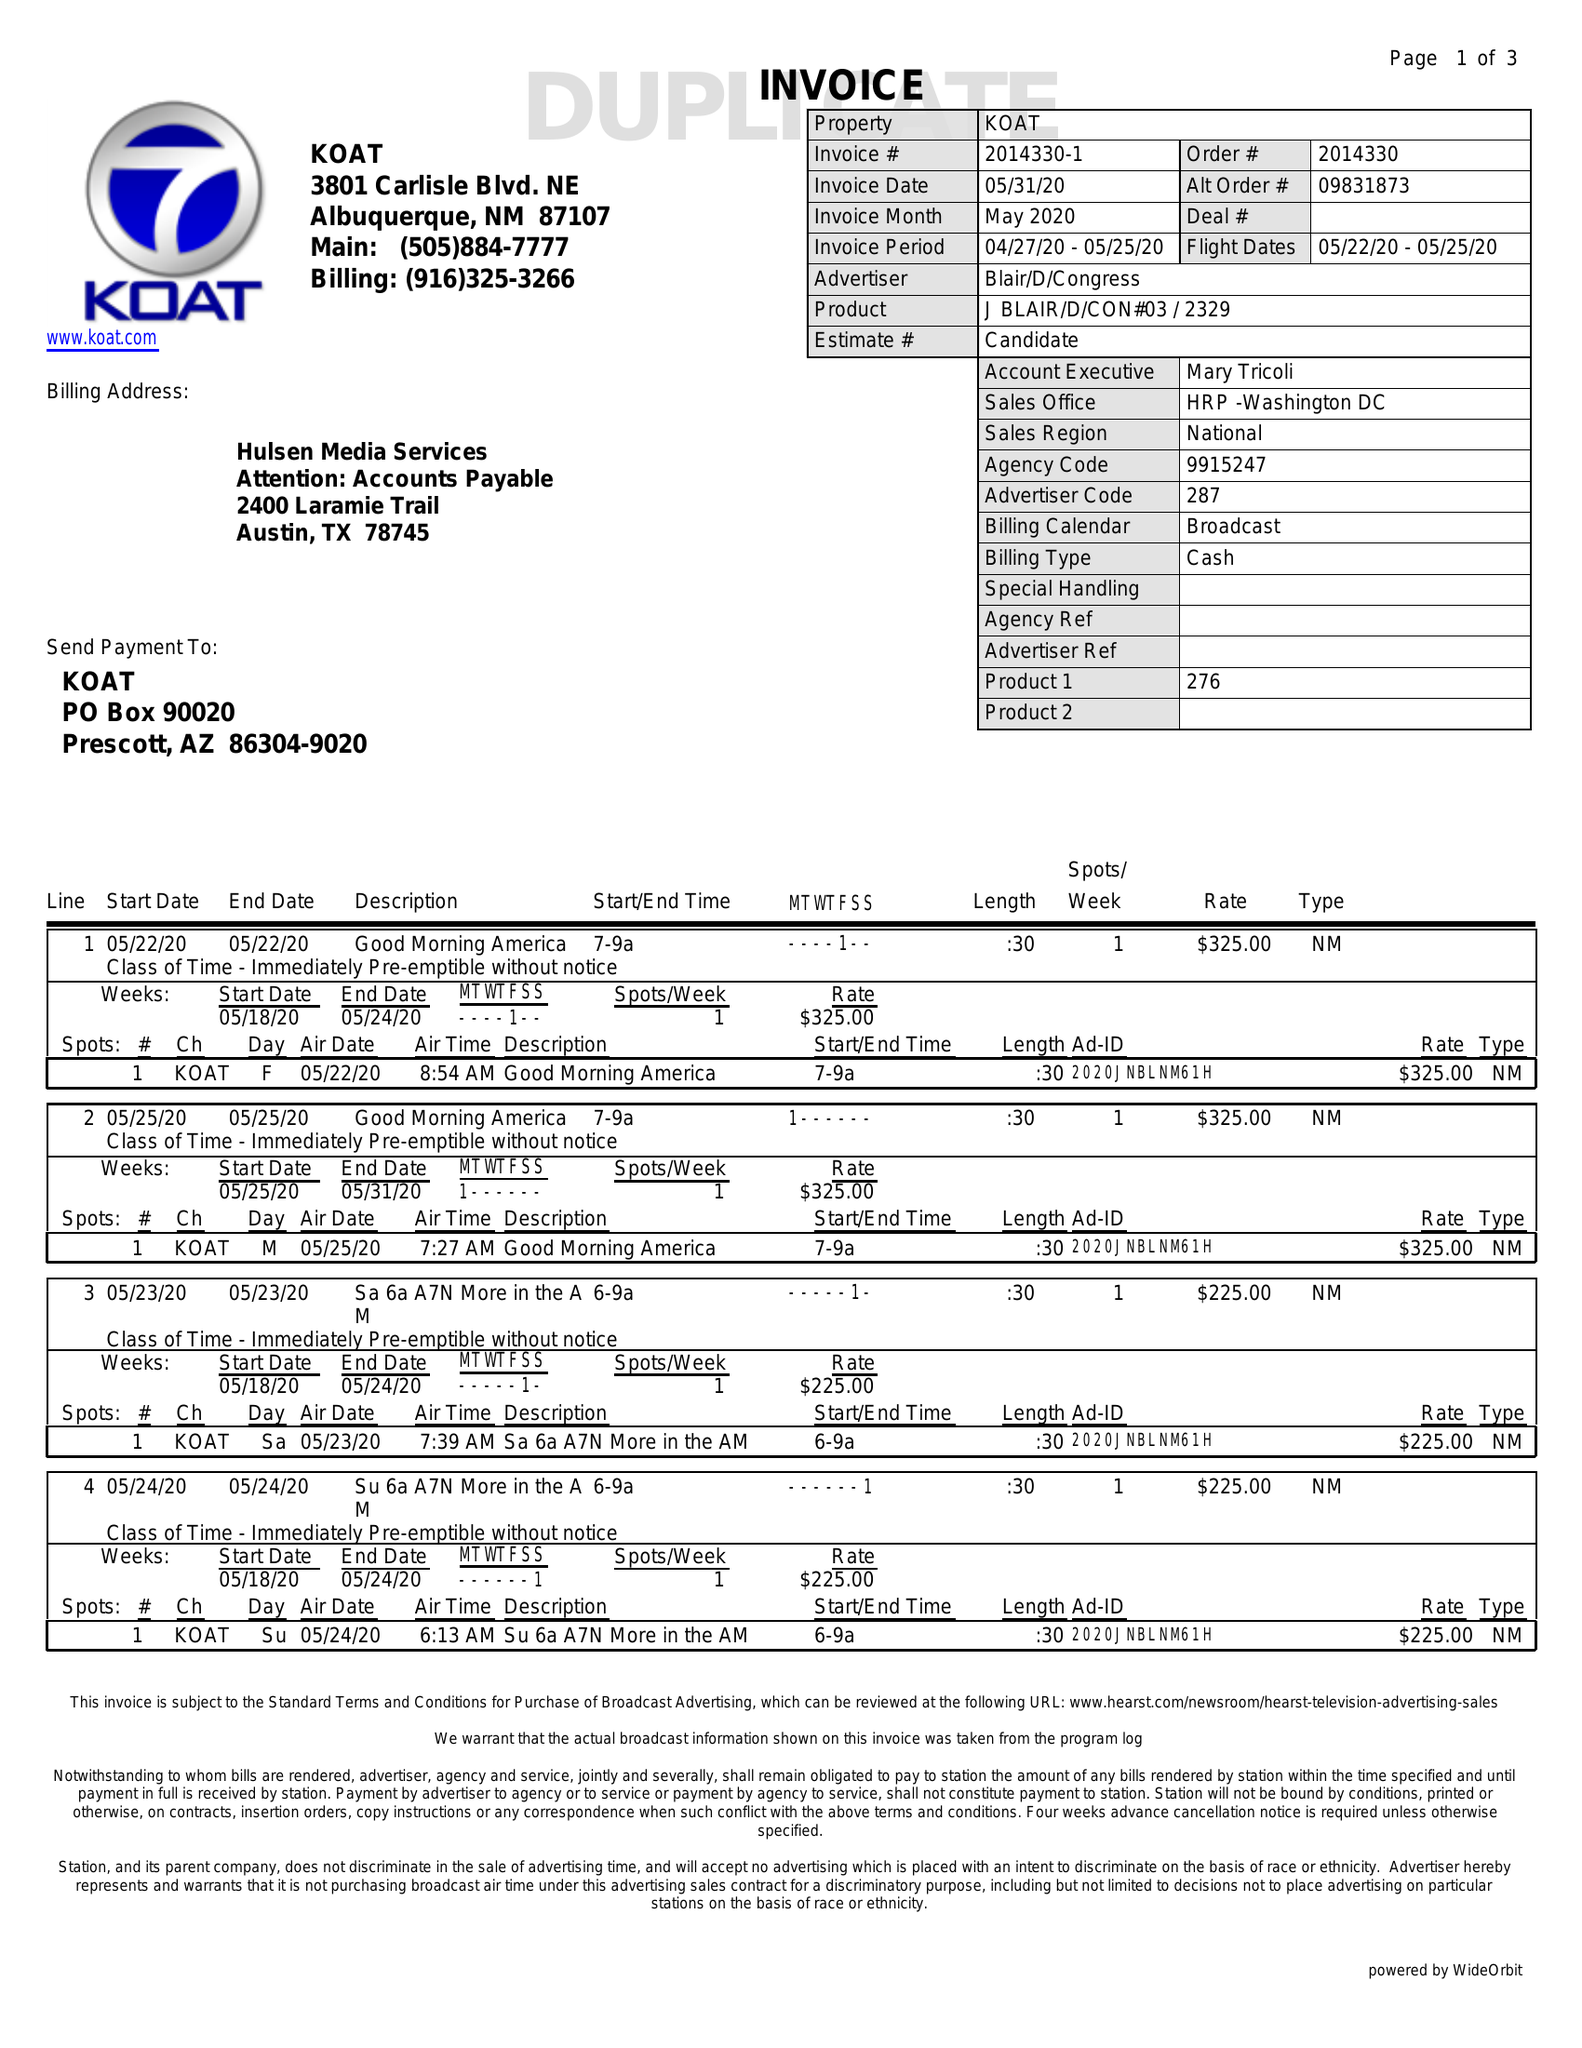What is the value for the flight_from?
Answer the question using a single word or phrase. 05/22/20 